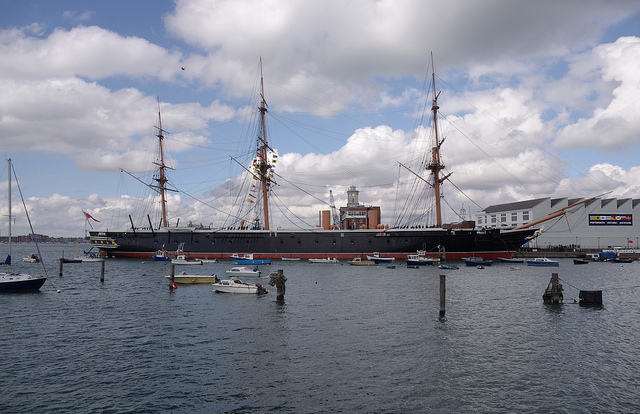<image>What flag is flying in image? There is no flag in the image. However, it may be an Indian, American or Dutch flag. What flag is flying in image? I don't know what flag is flying in the image. There are multiple answers given such as 'no flag', 'india flag', 'russian', 'none', 'american', 'dutch', and 'red'. 